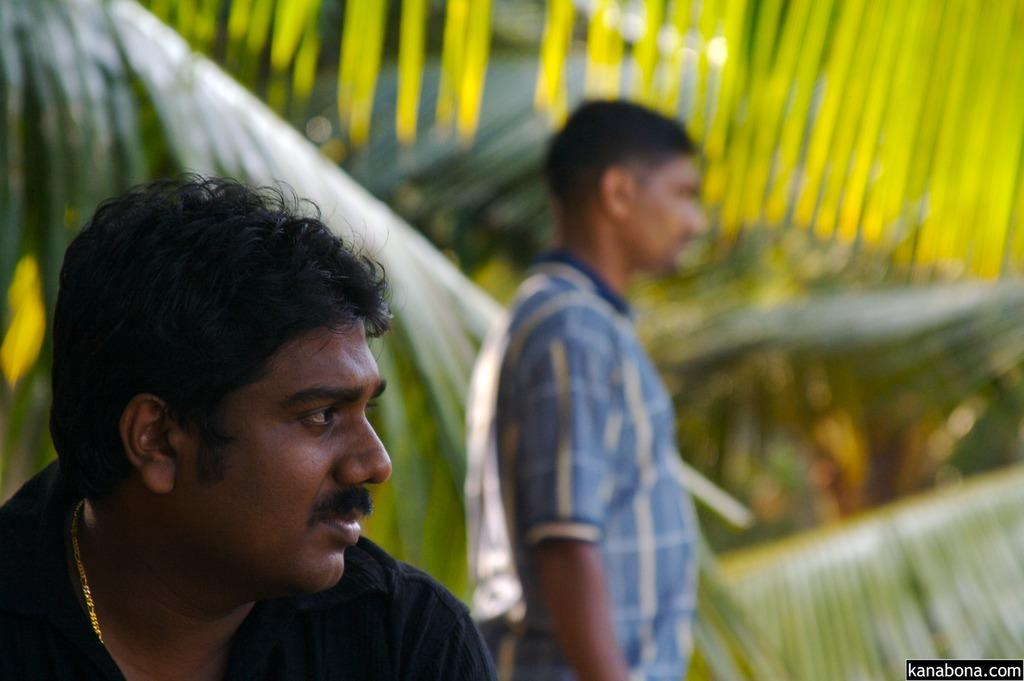How many people are in the image? There are two people in the image. What can be seen in the background of the image? There are leaves of coconut trees in the background. Is there any text present in the image? Yes, there is some text at the bottom of the image. What type of sand can be seen on the society in the image? There is no society or sand present in the image. 